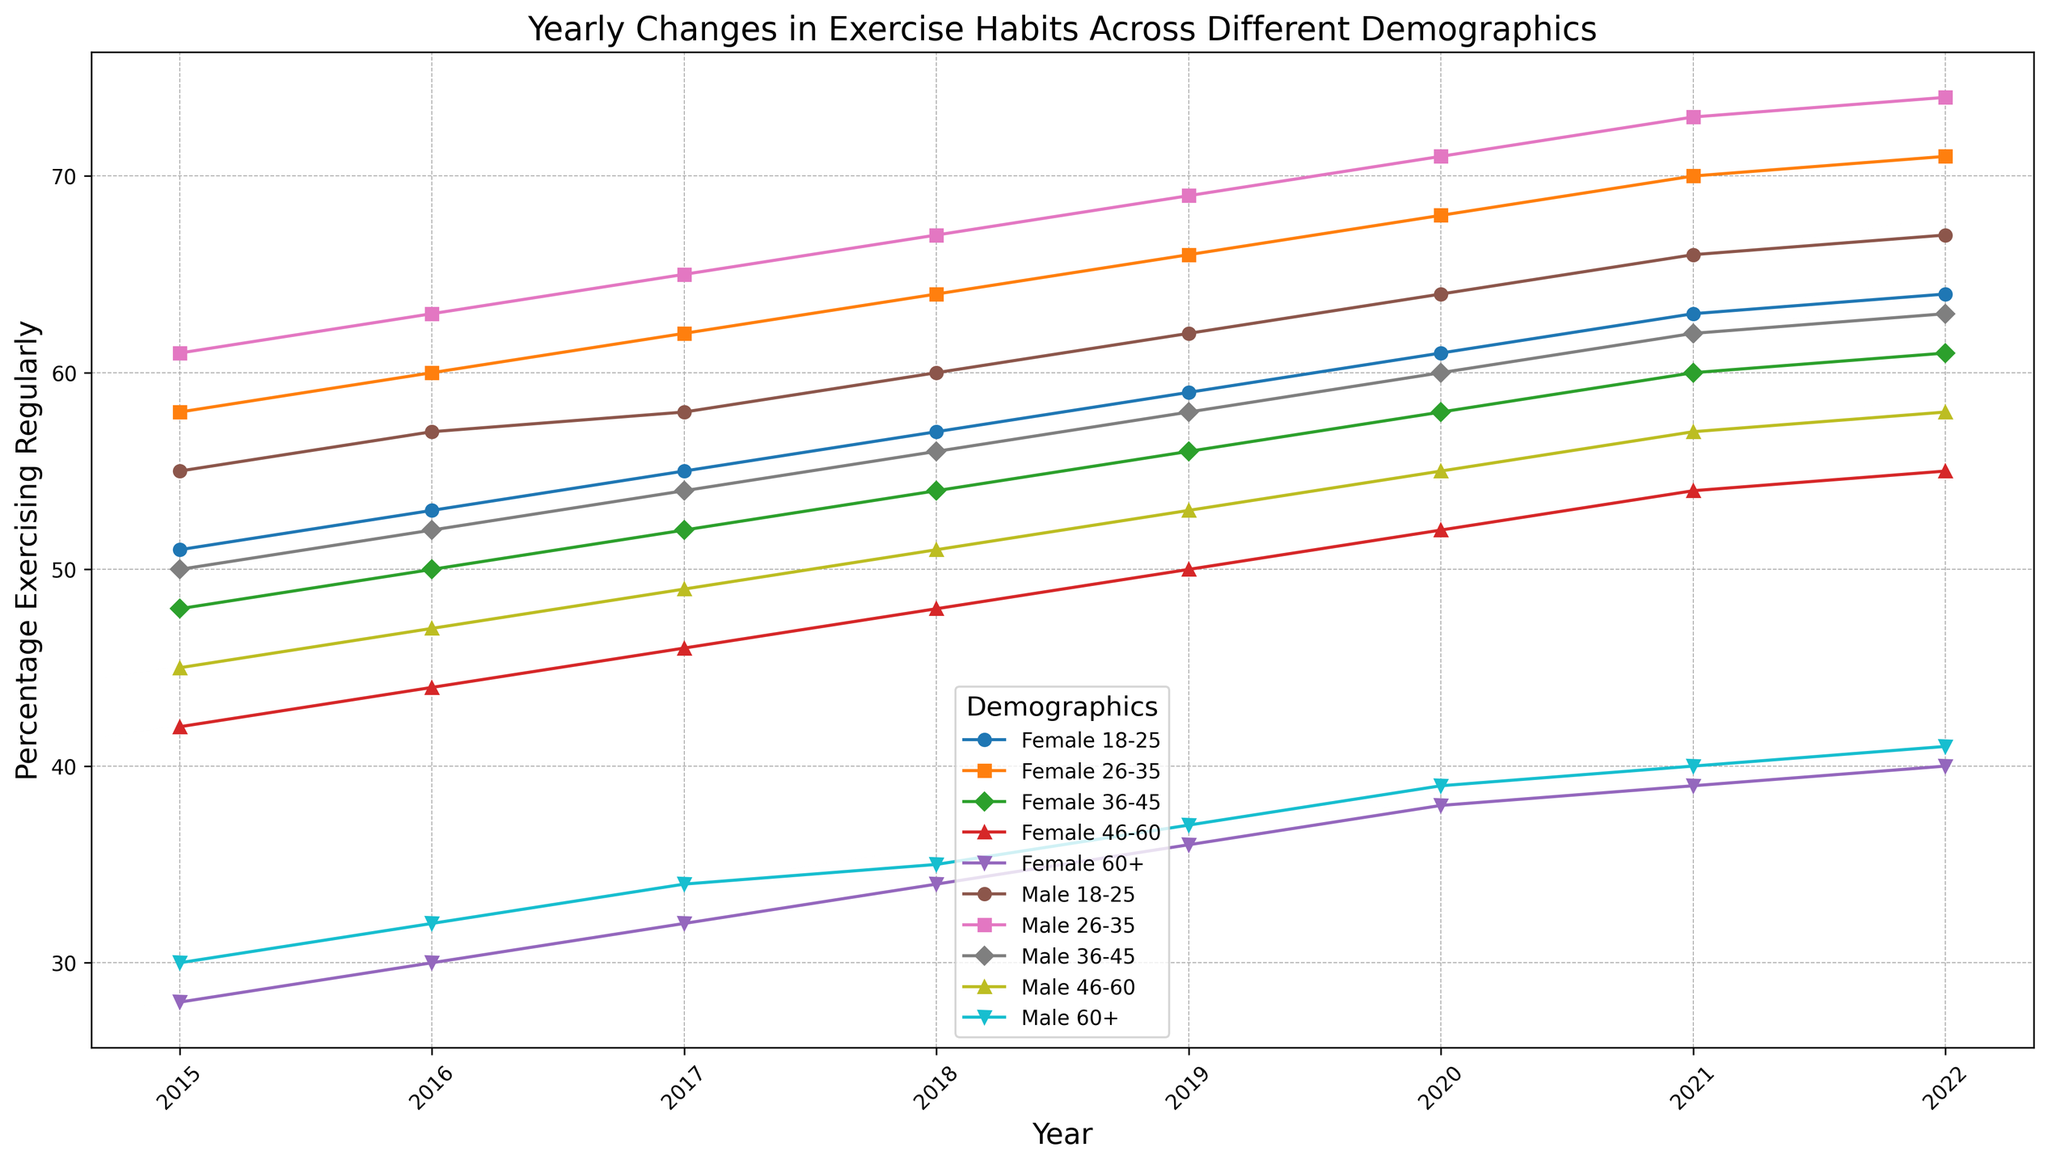What is the percentage increase in the 18-25 male group from 2015 to 2022? The percentage in the 18-25 male group in 2015 is 55%, and in 2022 it is 67%. The increase is calculated as 67% - 55% = 12%
Answer: 12% Which age group and gender had the highest percentage of individuals exercising regularly in 2022? In 2022, the highest percentage observed was in the 26-35 male group with 74%.
Answer: 26-35 male How does the percentage of 60+ female individuals exercising regularly in 2020 compare to that in 2017? In 2017, the 60+ female group had 32% exercising regularly, and in 2020, the percentage was 38%. 38% is higher than 32%.
Answer: Higher What is the trend in the percentage of 36-45 females exercising regularly from 2015 to 2022? From 2015 to 2022, the percentage of 36-45 females exercising regularly increased steadily from 48% to 61%.
Answer: Increasing trend What is the average percentage of the 26-35 female group exercising regularly over the years 2018-2022? The percentages for the 26-35 female group from 2018 to 2022 are 64%, 66%, 68%, 70%, 71%. The average is calculated as (64 + 66 + 68 + 70 + 71) / 5 = 67.8%.
Answer: 67.8% Which gender and age group show the smallest change in the percentage of individuals exercising regularly from 2015 to 2022? By visual inspection, the 60+ female group appears to have the smallest change, increasing from 28% in 2015 to 40% in 2022, a change of 12%.
Answer: 60+ female Is there any year in which the percentage of 46-60 males exercising regularly exceeds the percentage of 36-45 males? In 2015-2017, and from 2019 onwards, the percentage of 46-60 males is lower than that of 36-45 males. Only in 2018 did the 46-60 males (51%) exceed the 36-45 males (50%).
Answer: 2018 Compare the percentage of exercise habits between males and females in the 18-25 age group in 2016. In 2016, the percentage of 18-25 males exercising regularly was 57%, while that of females was 53%. Males exercised more than females by 4%.
Answer: Males exercised 4% more What is the difference in the percentage of individuals aged 46-60 (both genders) exercising regularly in 2015 and 2022? For 46-60 males, the percentage increases from 45% in 2015 to 58% in 2022, a difference of 13%. For 46-60 females, the percentage increases from 42% in 2015 to 55% in 2022, a difference of 13%.
Answer: 13% (both genders) Which demographic had the largest increase in the percentage of individuals exercising regularly between 2015 and 2022? The 26-35 male group had an increase from 61% in 2015 to 74% in 2022, resulting in a 13% increase, the largest among all demographics.
Answer: 26-35 male 